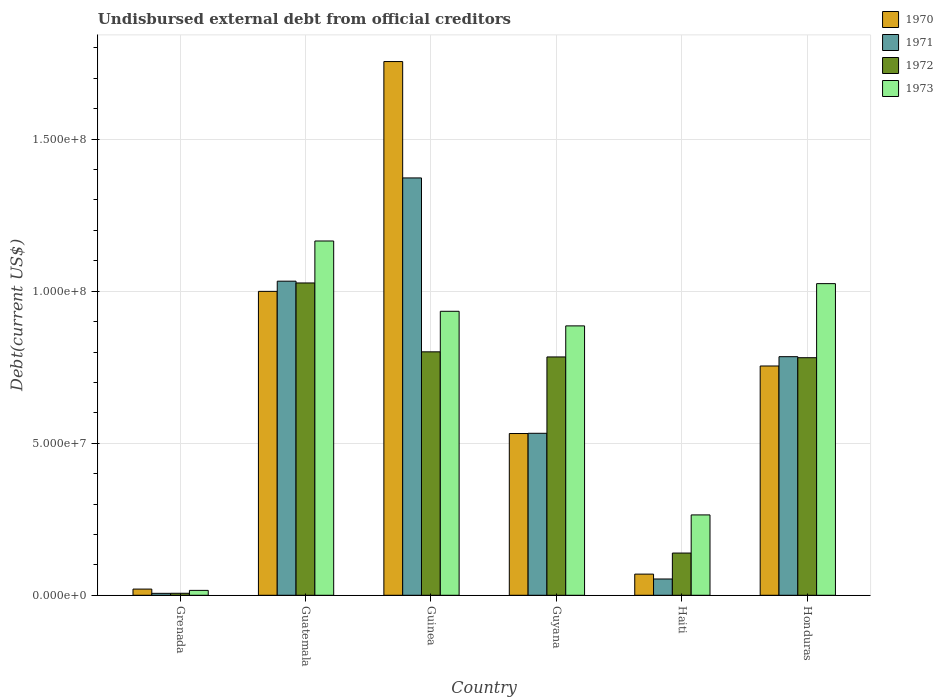Are the number of bars per tick equal to the number of legend labels?
Offer a terse response. Yes. How many bars are there on the 6th tick from the left?
Offer a very short reply. 4. How many bars are there on the 3rd tick from the right?
Your answer should be very brief. 4. What is the label of the 1st group of bars from the left?
Your answer should be very brief. Grenada. What is the total debt in 1970 in Haiti?
Give a very brief answer. 6.96e+06. Across all countries, what is the maximum total debt in 1971?
Give a very brief answer. 1.37e+08. Across all countries, what is the minimum total debt in 1972?
Make the answer very short. 6.57e+05. In which country was the total debt in 1973 maximum?
Provide a succinct answer. Guatemala. In which country was the total debt in 1970 minimum?
Provide a short and direct response. Grenada. What is the total total debt in 1972 in the graph?
Give a very brief answer. 3.54e+08. What is the difference between the total debt in 1973 in Guyana and that in Haiti?
Offer a terse response. 6.22e+07. What is the difference between the total debt in 1972 in Honduras and the total debt in 1970 in Grenada?
Your answer should be very brief. 7.61e+07. What is the average total debt in 1972 per country?
Provide a short and direct response. 5.90e+07. What is the difference between the total debt of/in 1973 and total debt of/in 1970 in Honduras?
Your response must be concise. 2.71e+07. What is the ratio of the total debt in 1973 in Guatemala to that in Guinea?
Make the answer very short. 1.25. Is the difference between the total debt in 1973 in Grenada and Guyana greater than the difference between the total debt in 1970 in Grenada and Guyana?
Your answer should be very brief. No. What is the difference between the highest and the second highest total debt in 1970?
Your answer should be compact. 1.00e+08. What is the difference between the highest and the lowest total debt in 1972?
Give a very brief answer. 1.02e+08. In how many countries, is the total debt in 1972 greater than the average total debt in 1972 taken over all countries?
Keep it short and to the point. 4. Is the sum of the total debt in 1972 in Guinea and Guyana greater than the maximum total debt in 1973 across all countries?
Your answer should be compact. Yes. Is it the case that in every country, the sum of the total debt in 1973 and total debt in 1970 is greater than the sum of total debt in 1972 and total debt in 1971?
Offer a terse response. No. What does the 2nd bar from the right in Guatemala represents?
Give a very brief answer. 1972. How many countries are there in the graph?
Provide a short and direct response. 6. What is the difference between two consecutive major ticks on the Y-axis?
Offer a very short reply. 5.00e+07. Are the values on the major ticks of Y-axis written in scientific E-notation?
Provide a short and direct response. Yes. Does the graph contain any zero values?
Keep it short and to the point. No. Does the graph contain grids?
Your answer should be very brief. Yes. Where does the legend appear in the graph?
Give a very brief answer. Top right. How many legend labels are there?
Offer a terse response. 4. How are the legend labels stacked?
Your answer should be compact. Vertical. What is the title of the graph?
Ensure brevity in your answer.  Undisbursed external debt from official creditors. Does "2014" appear as one of the legend labels in the graph?
Your response must be concise. No. What is the label or title of the X-axis?
Your answer should be very brief. Country. What is the label or title of the Y-axis?
Provide a succinct answer. Debt(current US$). What is the Debt(current US$) of 1970 in Grenada?
Your answer should be very brief. 2.04e+06. What is the Debt(current US$) of 1971 in Grenada?
Your answer should be very brief. 6.39e+05. What is the Debt(current US$) of 1972 in Grenada?
Your response must be concise. 6.57e+05. What is the Debt(current US$) in 1973 in Grenada?
Make the answer very short. 1.61e+06. What is the Debt(current US$) of 1970 in Guatemala?
Offer a terse response. 9.99e+07. What is the Debt(current US$) of 1971 in Guatemala?
Keep it short and to the point. 1.03e+08. What is the Debt(current US$) of 1972 in Guatemala?
Provide a short and direct response. 1.03e+08. What is the Debt(current US$) in 1973 in Guatemala?
Your answer should be compact. 1.17e+08. What is the Debt(current US$) in 1970 in Guinea?
Provide a succinct answer. 1.76e+08. What is the Debt(current US$) in 1971 in Guinea?
Your response must be concise. 1.37e+08. What is the Debt(current US$) in 1972 in Guinea?
Provide a short and direct response. 8.01e+07. What is the Debt(current US$) in 1973 in Guinea?
Provide a short and direct response. 9.34e+07. What is the Debt(current US$) in 1970 in Guyana?
Keep it short and to the point. 5.32e+07. What is the Debt(current US$) of 1971 in Guyana?
Your answer should be compact. 5.33e+07. What is the Debt(current US$) in 1972 in Guyana?
Your answer should be very brief. 7.84e+07. What is the Debt(current US$) in 1973 in Guyana?
Provide a short and direct response. 8.86e+07. What is the Debt(current US$) in 1970 in Haiti?
Give a very brief answer. 6.96e+06. What is the Debt(current US$) of 1971 in Haiti?
Provide a succinct answer. 5.35e+06. What is the Debt(current US$) in 1972 in Haiti?
Give a very brief answer. 1.39e+07. What is the Debt(current US$) of 1973 in Haiti?
Provide a succinct answer. 2.64e+07. What is the Debt(current US$) in 1970 in Honduras?
Your response must be concise. 7.54e+07. What is the Debt(current US$) in 1971 in Honduras?
Keep it short and to the point. 7.85e+07. What is the Debt(current US$) of 1972 in Honduras?
Give a very brief answer. 7.81e+07. What is the Debt(current US$) in 1973 in Honduras?
Offer a very short reply. 1.02e+08. Across all countries, what is the maximum Debt(current US$) of 1970?
Your response must be concise. 1.76e+08. Across all countries, what is the maximum Debt(current US$) in 1971?
Your answer should be compact. 1.37e+08. Across all countries, what is the maximum Debt(current US$) of 1972?
Make the answer very short. 1.03e+08. Across all countries, what is the maximum Debt(current US$) of 1973?
Provide a short and direct response. 1.17e+08. Across all countries, what is the minimum Debt(current US$) of 1970?
Make the answer very short. 2.04e+06. Across all countries, what is the minimum Debt(current US$) in 1971?
Your response must be concise. 6.39e+05. Across all countries, what is the minimum Debt(current US$) in 1972?
Your answer should be very brief. 6.57e+05. Across all countries, what is the minimum Debt(current US$) of 1973?
Ensure brevity in your answer.  1.61e+06. What is the total Debt(current US$) in 1970 in the graph?
Your response must be concise. 4.13e+08. What is the total Debt(current US$) of 1971 in the graph?
Make the answer very short. 3.78e+08. What is the total Debt(current US$) of 1972 in the graph?
Ensure brevity in your answer.  3.54e+08. What is the total Debt(current US$) of 1973 in the graph?
Offer a very short reply. 4.29e+08. What is the difference between the Debt(current US$) of 1970 in Grenada and that in Guatemala?
Your answer should be compact. -9.79e+07. What is the difference between the Debt(current US$) of 1971 in Grenada and that in Guatemala?
Offer a very short reply. -1.03e+08. What is the difference between the Debt(current US$) in 1972 in Grenada and that in Guatemala?
Your response must be concise. -1.02e+08. What is the difference between the Debt(current US$) of 1973 in Grenada and that in Guatemala?
Keep it short and to the point. -1.15e+08. What is the difference between the Debt(current US$) of 1970 in Grenada and that in Guinea?
Offer a very short reply. -1.73e+08. What is the difference between the Debt(current US$) in 1971 in Grenada and that in Guinea?
Ensure brevity in your answer.  -1.37e+08. What is the difference between the Debt(current US$) in 1972 in Grenada and that in Guinea?
Make the answer very short. -7.94e+07. What is the difference between the Debt(current US$) in 1973 in Grenada and that in Guinea?
Offer a very short reply. -9.18e+07. What is the difference between the Debt(current US$) in 1970 in Grenada and that in Guyana?
Make the answer very short. -5.12e+07. What is the difference between the Debt(current US$) in 1971 in Grenada and that in Guyana?
Your response must be concise. -5.26e+07. What is the difference between the Debt(current US$) of 1972 in Grenada and that in Guyana?
Keep it short and to the point. -7.77e+07. What is the difference between the Debt(current US$) in 1973 in Grenada and that in Guyana?
Provide a succinct answer. -8.70e+07. What is the difference between the Debt(current US$) of 1970 in Grenada and that in Haiti?
Provide a succinct answer. -4.92e+06. What is the difference between the Debt(current US$) in 1971 in Grenada and that in Haiti?
Ensure brevity in your answer.  -4.71e+06. What is the difference between the Debt(current US$) in 1972 in Grenada and that in Haiti?
Give a very brief answer. -1.32e+07. What is the difference between the Debt(current US$) in 1973 in Grenada and that in Haiti?
Keep it short and to the point. -2.48e+07. What is the difference between the Debt(current US$) in 1970 in Grenada and that in Honduras?
Offer a very short reply. -7.34e+07. What is the difference between the Debt(current US$) of 1971 in Grenada and that in Honduras?
Your answer should be compact. -7.78e+07. What is the difference between the Debt(current US$) of 1972 in Grenada and that in Honduras?
Give a very brief answer. -7.75e+07. What is the difference between the Debt(current US$) of 1973 in Grenada and that in Honduras?
Offer a terse response. -1.01e+08. What is the difference between the Debt(current US$) in 1970 in Guatemala and that in Guinea?
Your answer should be very brief. -7.56e+07. What is the difference between the Debt(current US$) of 1971 in Guatemala and that in Guinea?
Ensure brevity in your answer.  -3.40e+07. What is the difference between the Debt(current US$) in 1972 in Guatemala and that in Guinea?
Your answer should be compact. 2.27e+07. What is the difference between the Debt(current US$) of 1973 in Guatemala and that in Guinea?
Make the answer very short. 2.31e+07. What is the difference between the Debt(current US$) in 1970 in Guatemala and that in Guyana?
Your answer should be very brief. 4.67e+07. What is the difference between the Debt(current US$) of 1971 in Guatemala and that in Guyana?
Make the answer very short. 5.00e+07. What is the difference between the Debt(current US$) in 1972 in Guatemala and that in Guyana?
Provide a short and direct response. 2.43e+07. What is the difference between the Debt(current US$) of 1973 in Guatemala and that in Guyana?
Keep it short and to the point. 2.79e+07. What is the difference between the Debt(current US$) in 1970 in Guatemala and that in Haiti?
Make the answer very short. 9.30e+07. What is the difference between the Debt(current US$) of 1971 in Guatemala and that in Haiti?
Provide a short and direct response. 9.79e+07. What is the difference between the Debt(current US$) of 1972 in Guatemala and that in Haiti?
Your answer should be compact. 8.88e+07. What is the difference between the Debt(current US$) of 1973 in Guatemala and that in Haiti?
Ensure brevity in your answer.  9.01e+07. What is the difference between the Debt(current US$) of 1970 in Guatemala and that in Honduras?
Offer a terse response. 2.45e+07. What is the difference between the Debt(current US$) of 1971 in Guatemala and that in Honduras?
Keep it short and to the point. 2.48e+07. What is the difference between the Debt(current US$) of 1972 in Guatemala and that in Honduras?
Ensure brevity in your answer.  2.46e+07. What is the difference between the Debt(current US$) in 1973 in Guatemala and that in Honduras?
Ensure brevity in your answer.  1.40e+07. What is the difference between the Debt(current US$) of 1970 in Guinea and that in Guyana?
Make the answer very short. 1.22e+08. What is the difference between the Debt(current US$) in 1971 in Guinea and that in Guyana?
Your answer should be compact. 8.40e+07. What is the difference between the Debt(current US$) in 1972 in Guinea and that in Guyana?
Your response must be concise. 1.68e+06. What is the difference between the Debt(current US$) of 1973 in Guinea and that in Guyana?
Provide a short and direct response. 4.80e+06. What is the difference between the Debt(current US$) in 1970 in Guinea and that in Haiti?
Ensure brevity in your answer.  1.69e+08. What is the difference between the Debt(current US$) in 1971 in Guinea and that in Haiti?
Your answer should be compact. 1.32e+08. What is the difference between the Debt(current US$) of 1972 in Guinea and that in Haiti?
Your response must be concise. 6.62e+07. What is the difference between the Debt(current US$) in 1973 in Guinea and that in Haiti?
Your answer should be very brief. 6.70e+07. What is the difference between the Debt(current US$) in 1970 in Guinea and that in Honduras?
Your response must be concise. 1.00e+08. What is the difference between the Debt(current US$) of 1971 in Guinea and that in Honduras?
Ensure brevity in your answer.  5.88e+07. What is the difference between the Debt(current US$) of 1972 in Guinea and that in Honduras?
Your answer should be very brief. 1.93e+06. What is the difference between the Debt(current US$) of 1973 in Guinea and that in Honduras?
Provide a succinct answer. -9.10e+06. What is the difference between the Debt(current US$) of 1970 in Guyana and that in Haiti?
Keep it short and to the point. 4.62e+07. What is the difference between the Debt(current US$) of 1971 in Guyana and that in Haiti?
Provide a succinct answer. 4.79e+07. What is the difference between the Debt(current US$) of 1972 in Guyana and that in Haiti?
Your response must be concise. 6.45e+07. What is the difference between the Debt(current US$) in 1973 in Guyana and that in Haiti?
Give a very brief answer. 6.22e+07. What is the difference between the Debt(current US$) of 1970 in Guyana and that in Honduras?
Your response must be concise. -2.22e+07. What is the difference between the Debt(current US$) of 1971 in Guyana and that in Honduras?
Offer a terse response. -2.52e+07. What is the difference between the Debt(current US$) of 1972 in Guyana and that in Honduras?
Keep it short and to the point. 2.49e+05. What is the difference between the Debt(current US$) in 1973 in Guyana and that in Honduras?
Your answer should be very brief. -1.39e+07. What is the difference between the Debt(current US$) in 1970 in Haiti and that in Honduras?
Make the answer very short. -6.84e+07. What is the difference between the Debt(current US$) of 1971 in Haiti and that in Honduras?
Your answer should be very brief. -7.31e+07. What is the difference between the Debt(current US$) in 1972 in Haiti and that in Honduras?
Keep it short and to the point. -6.42e+07. What is the difference between the Debt(current US$) in 1973 in Haiti and that in Honduras?
Provide a short and direct response. -7.61e+07. What is the difference between the Debt(current US$) of 1970 in Grenada and the Debt(current US$) of 1971 in Guatemala?
Offer a terse response. -1.01e+08. What is the difference between the Debt(current US$) of 1970 in Grenada and the Debt(current US$) of 1972 in Guatemala?
Give a very brief answer. -1.01e+08. What is the difference between the Debt(current US$) in 1970 in Grenada and the Debt(current US$) in 1973 in Guatemala?
Your answer should be very brief. -1.14e+08. What is the difference between the Debt(current US$) of 1971 in Grenada and the Debt(current US$) of 1972 in Guatemala?
Your response must be concise. -1.02e+08. What is the difference between the Debt(current US$) in 1971 in Grenada and the Debt(current US$) in 1973 in Guatemala?
Your answer should be compact. -1.16e+08. What is the difference between the Debt(current US$) of 1972 in Grenada and the Debt(current US$) of 1973 in Guatemala?
Your response must be concise. -1.16e+08. What is the difference between the Debt(current US$) in 1970 in Grenada and the Debt(current US$) in 1971 in Guinea?
Offer a terse response. -1.35e+08. What is the difference between the Debt(current US$) of 1970 in Grenada and the Debt(current US$) of 1972 in Guinea?
Keep it short and to the point. -7.80e+07. What is the difference between the Debt(current US$) in 1970 in Grenada and the Debt(current US$) in 1973 in Guinea?
Provide a succinct answer. -9.14e+07. What is the difference between the Debt(current US$) in 1971 in Grenada and the Debt(current US$) in 1972 in Guinea?
Your answer should be very brief. -7.94e+07. What is the difference between the Debt(current US$) of 1971 in Grenada and the Debt(current US$) of 1973 in Guinea?
Ensure brevity in your answer.  -9.28e+07. What is the difference between the Debt(current US$) of 1972 in Grenada and the Debt(current US$) of 1973 in Guinea?
Your answer should be compact. -9.27e+07. What is the difference between the Debt(current US$) of 1970 in Grenada and the Debt(current US$) of 1971 in Guyana?
Your answer should be very brief. -5.12e+07. What is the difference between the Debt(current US$) in 1970 in Grenada and the Debt(current US$) in 1972 in Guyana?
Your response must be concise. -7.63e+07. What is the difference between the Debt(current US$) in 1970 in Grenada and the Debt(current US$) in 1973 in Guyana?
Offer a very short reply. -8.66e+07. What is the difference between the Debt(current US$) in 1971 in Grenada and the Debt(current US$) in 1972 in Guyana?
Provide a succinct answer. -7.77e+07. What is the difference between the Debt(current US$) in 1971 in Grenada and the Debt(current US$) in 1973 in Guyana?
Give a very brief answer. -8.80e+07. What is the difference between the Debt(current US$) in 1972 in Grenada and the Debt(current US$) in 1973 in Guyana?
Offer a terse response. -8.79e+07. What is the difference between the Debt(current US$) of 1970 in Grenada and the Debt(current US$) of 1971 in Haiti?
Give a very brief answer. -3.32e+06. What is the difference between the Debt(current US$) in 1970 in Grenada and the Debt(current US$) in 1972 in Haiti?
Provide a short and direct response. -1.18e+07. What is the difference between the Debt(current US$) of 1970 in Grenada and the Debt(current US$) of 1973 in Haiti?
Your response must be concise. -2.44e+07. What is the difference between the Debt(current US$) in 1971 in Grenada and the Debt(current US$) in 1972 in Haiti?
Your response must be concise. -1.32e+07. What is the difference between the Debt(current US$) in 1971 in Grenada and the Debt(current US$) in 1973 in Haiti?
Provide a short and direct response. -2.58e+07. What is the difference between the Debt(current US$) in 1972 in Grenada and the Debt(current US$) in 1973 in Haiti?
Give a very brief answer. -2.58e+07. What is the difference between the Debt(current US$) of 1970 in Grenada and the Debt(current US$) of 1971 in Honduras?
Keep it short and to the point. -7.64e+07. What is the difference between the Debt(current US$) of 1970 in Grenada and the Debt(current US$) of 1972 in Honduras?
Make the answer very short. -7.61e+07. What is the difference between the Debt(current US$) of 1970 in Grenada and the Debt(current US$) of 1973 in Honduras?
Offer a very short reply. -1.00e+08. What is the difference between the Debt(current US$) of 1971 in Grenada and the Debt(current US$) of 1972 in Honduras?
Ensure brevity in your answer.  -7.75e+07. What is the difference between the Debt(current US$) in 1971 in Grenada and the Debt(current US$) in 1973 in Honduras?
Keep it short and to the point. -1.02e+08. What is the difference between the Debt(current US$) in 1972 in Grenada and the Debt(current US$) in 1973 in Honduras?
Ensure brevity in your answer.  -1.02e+08. What is the difference between the Debt(current US$) of 1970 in Guatemala and the Debt(current US$) of 1971 in Guinea?
Ensure brevity in your answer.  -3.73e+07. What is the difference between the Debt(current US$) of 1970 in Guatemala and the Debt(current US$) of 1972 in Guinea?
Keep it short and to the point. 1.99e+07. What is the difference between the Debt(current US$) of 1970 in Guatemala and the Debt(current US$) of 1973 in Guinea?
Give a very brief answer. 6.55e+06. What is the difference between the Debt(current US$) of 1971 in Guatemala and the Debt(current US$) of 1972 in Guinea?
Your answer should be very brief. 2.32e+07. What is the difference between the Debt(current US$) in 1971 in Guatemala and the Debt(current US$) in 1973 in Guinea?
Ensure brevity in your answer.  9.90e+06. What is the difference between the Debt(current US$) of 1972 in Guatemala and the Debt(current US$) of 1973 in Guinea?
Make the answer very short. 9.32e+06. What is the difference between the Debt(current US$) in 1970 in Guatemala and the Debt(current US$) in 1971 in Guyana?
Offer a terse response. 4.67e+07. What is the difference between the Debt(current US$) in 1970 in Guatemala and the Debt(current US$) in 1972 in Guyana?
Provide a short and direct response. 2.16e+07. What is the difference between the Debt(current US$) in 1970 in Guatemala and the Debt(current US$) in 1973 in Guyana?
Provide a short and direct response. 1.14e+07. What is the difference between the Debt(current US$) of 1971 in Guatemala and the Debt(current US$) of 1972 in Guyana?
Ensure brevity in your answer.  2.49e+07. What is the difference between the Debt(current US$) in 1971 in Guatemala and the Debt(current US$) in 1973 in Guyana?
Your response must be concise. 1.47e+07. What is the difference between the Debt(current US$) in 1972 in Guatemala and the Debt(current US$) in 1973 in Guyana?
Provide a short and direct response. 1.41e+07. What is the difference between the Debt(current US$) in 1970 in Guatemala and the Debt(current US$) in 1971 in Haiti?
Offer a very short reply. 9.46e+07. What is the difference between the Debt(current US$) of 1970 in Guatemala and the Debt(current US$) of 1972 in Haiti?
Your answer should be very brief. 8.61e+07. What is the difference between the Debt(current US$) in 1970 in Guatemala and the Debt(current US$) in 1973 in Haiti?
Your answer should be compact. 7.35e+07. What is the difference between the Debt(current US$) of 1971 in Guatemala and the Debt(current US$) of 1972 in Haiti?
Provide a short and direct response. 8.94e+07. What is the difference between the Debt(current US$) in 1971 in Guatemala and the Debt(current US$) in 1973 in Haiti?
Make the answer very short. 7.69e+07. What is the difference between the Debt(current US$) of 1972 in Guatemala and the Debt(current US$) of 1973 in Haiti?
Your answer should be compact. 7.63e+07. What is the difference between the Debt(current US$) of 1970 in Guatemala and the Debt(current US$) of 1971 in Honduras?
Ensure brevity in your answer.  2.15e+07. What is the difference between the Debt(current US$) in 1970 in Guatemala and the Debt(current US$) in 1972 in Honduras?
Offer a terse response. 2.18e+07. What is the difference between the Debt(current US$) of 1970 in Guatemala and the Debt(current US$) of 1973 in Honduras?
Ensure brevity in your answer.  -2.55e+06. What is the difference between the Debt(current US$) in 1971 in Guatemala and the Debt(current US$) in 1972 in Honduras?
Make the answer very short. 2.52e+07. What is the difference between the Debt(current US$) of 1971 in Guatemala and the Debt(current US$) of 1973 in Honduras?
Give a very brief answer. 8.06e+05. What is the difference between the Debt(current US$) of 1972 in Guatemala and the Debt(current US$) of 1973 in Honduras?
Your response must be concise. 2.19e+05. What is the difference between the Debt(current US$) in 1970 in Guinea and the Debt(current US$) in 1971 in Guyana?
Your answer should be very brief. 1.22e+08. What is the difference between the Debt(current US$) in 1970 in Guinea and the Debt(current US$) in 1972 in Guyana?
Give a very brief answer. 9.71e+07. What is the difference between the Debt(current US$) in 1970 in Guinea and the Debt(current US$) in 1973 in Guyana?
Offer a terse response. 8.69e+07. What is the difference between the Debt(current US$) of 1971 in Guinea and the Debt(current US$) of 1972 in Guyana?
Make the answer very short. 5.89e+07. What is the difference between the Debt(current US$) of 1971 in Guinea and the Debt(current US$) of 1973 in Guyana?
Your answer should be very brief. 4.87e+07. What is the difference between the Debt(current US$) in 1972 in Guinea and the Debt(current US$) in 1973 in Guyana?
Ensure brevity in your answer.  -8.54e+06. What is the difference between the Debt(current US$) in 1970 in Guinea and the Debt(current US$) in 1971 in Haiti?
Make the answer very short. 1.70e+08. What is the difference between the Debt(current US$) of 1970 in Guinea and the Debt(current US$) of 1972 in Haiti?
Provide a succinct answer. 1.62e+08. What is the difference between the Debt(current US$) of 1970 in Guinea and the Debt(current US$) of 1973 in Haiti?
Keep it short and to the point. 1.49e+08. What is the difference between the Debt(current US$) in 1971 in Guinea and the Debt(current US$) in 1972 in Haiti?
Give a very brief answer. 1.23e+08. What is the difference between the Debt(current US$) of 1971 in Guinea and the Debt(current US$) of 1973 in Haiti?
Make the answer very short. 1.11e+08. What is the difference between the Debt(current US$) of 1972 in Guinea and the Debt(current US$) of 1973 in Haiti?
Make the answer very short. 5.36e+07. What is the difference between the Debt(current US$) in 1970 in Guinea and the Debt(current US$) in 1971 in Honduras?
Provide a succinct answer. 9.71e+07. What is the difference between the Debt(current US$) of 1970 in Guinea and the Debt(current US$) of 1972 in Honduras?
Keep it short and to the point. 9.74e+07. What is the difference between the Debt(current US$) of 1970 in Guinea and the Debt(current US$) of 1973 in Honduras?
Your answer should be very brief. 7.30e+07. What is the difference between the Debt(current US$) in 1971 in Guinea and the Debt(current US$) in 1972 in Honduras?
Make the answer very short. 5.91e+07. What is the difference between the Debt(current US$) of 1971 in Guinea and the Debt(current US$) of 1973 in Honduras?
Your answer should be compact. 3.48e+07. What is the difference between the Debt(current US$) in 1972 in Guinea and the Debt(current US$) in 1973 in Honduras?
Provide a succinct answer. -2.24e+07. What is the difference between the Debt(current US$) in 1970 in Guyana and the Debt(current US$) in 1971 in Haiti?
Provide a short and direct response. 4.78e+07. What is the difference between the Debt(current US$) in 1970 in Guyana and the Debt(current US$) in 1972 in Haiti?
Your answer should be very brief. 3.93e+07. What is the difference between the Debt(current US$) in 1970 in Guyana and the Debt(current US$) in 1973 in Haiti?
Offer a terse response. 2.68e+07. What is the difference between the Debt(current US$) in 1971 in Guyana and the Debt(current US$) in 1972 in Haiti?
Keep it short and to the point. 3.94e+07. What is the difference between the Debt(current US$) in 1971 in Guyana and the Debt(current US$) in 1973 in Haiti?
Provide a succinct answer. 2.68e+07. What is the difference between the Debt(current US$) in 1972 in Guyana and the Debt(current US$) in 1973 in Haiti?
Make the answer very short. 5.19e+07. What is the difference between the Debt(current US$) of 1970 in Guyana and the Debt(current US$) of 1971 in Honduras?
Keep it short and to the point. -2.53e+07. What is the difference between the Debt(current US$) of 1970 in Guyana and the Debt(current US$) of 1972 in Honduras?
Offer a very short reply. -2.49e+07. What is the difference between the Debt(current US$) of 1970 in Guyana and the Debt(current US$) of 1973 in Honduras?
Provide a succinct answer. -4.93e+07. What is the difference between the Debt(current US$) in 1971 in Guyana and the Debt(current US$) in 1972 in Honduras?
Provide a succinct answer. -2.49e+07. What is the difference between the Debt(current US$) of 1971 in Guyana and the Debt(current US$) of 1973 in Honduras?
Ensure brevity in your answer.  -4.92e+07. What is the difference between the Debt(current US$) of 1972 in Guyana and the Debt(current US$) of 1973 in Honduras?
Your answer should be very brief. -2.41e+07. What is the difference between the Debt(current US$) of 1970 in Haiti and the Debt(current US$) of 1971 in Honduras?
Make the answer very short. -7.15e+07. What is the difference between the Debt(current US$) of 1970 in Haiti and the Debt(current US$) of 1972 in Honduras?
Make the answer very short. -7.12e+07. What is the difference between the Debt(current US$) in 1970 in Haiti and the Debt(current US$) in 1973 in Honduras?
Your response must be concise. -9.55e+07. What is the difference between the Debt(current US$) in 1971 in Haiti and the Debt(current US$) in 1972 in Honduras?
Offer a terse response. -7.28e+07. What is the difference between the Debt(current US$) of 1971 in Haiti and the Debt(current US$) of 1973 in Honduras?
Your answer should be compact. -9.71e+07. What is the difference between the Debt(current US$) of 1972 in Haiti and the Debt(current US$) of 1973 in Honduras?
Offer a terse response. -8.86e+07. What is the average Debt(current US$) in 1970 per country?
Give a very brief answer. 6.88e+07. What is the average Debt(current US$) in 1971 per country?
Provide a short and direct response. 6.30e+07. What is the average Debt(current US$) in 1972 per country?
Keep it short and to the point. 5.90e+07. What is the average Debt(current US$) of 1973 per country?
Keep it short and to the point. 7.15e+07. What is the difference between the Debt(current US$) in 1970 and Debt(current US$) in 1971 in Grenada?
Your answer should be very brief. 1.40e+06. What is the difference between the Debt(current US$) in 1970 and Debt(current US$) in 1972 in Grenada?
Your answer should be compact. 1.38e+06. What is the difference between the Debt(current US$) of 1970 and Debt(current US$) of 1973 in Grenada?
Provide a succinct answer. 4.26e+05. What is the difference between the Debt(current US$) of 1971 and Debt(current US$) of 1972 in Grenada?
Give a very brief answer. -1.80e+04. What is the difference between the Debt(current US$) in 1971 and Debt(current US$) in 1973 in Grenada?
Your response must be concise. -9.72e+05. What is the difference between the Debt(current US$) in 1972 and Debt(current US$) in 1973 in Grenada?
Ensure brevity in your answer.  -9.54e+05. What is the difference between the Debt(current US$) in 1970 and Debt(current US$) in 1971 in Guatemala?
Keep it short and to the point. -3.35e+06. What is the difference between the Debt(current US$) in 1970 and Debt(current US$) in 1972 in Guatemala?
Provide a succinct answer. -2.77e+06. What is the difference between the Debt(current US$) in 1970 and Debt(current US$) in 1973 in Guatemala?
Offer a very short reply. -1.66e+07. What is the difference between the Debt(current US$) in 1971 and Debt(current US$) in 1972 in Guatemala?
Your answer should be very brief. 5.87e+05. What is the difference between the Debt(current US$) of 1971 and Debt(current US$) of 1973 in Guatemala?
Make the answer very short. -1.32e+07. What is the difference between the Debt(current US$) of 1972 and Debt(current US$) of 1973 in Guatemala?
Give a very brief answer. -1.38e+07. What is the difference between the Debt(current US$) of 1970 and Debt(current US$) of 1971 in Guinea?
Provide a short and direct response. 3.83e+07. What is the difference between the Debt(current US$) of 1970 and Debt(current US$) of 1972 in Guinea?
Keep it short and to the point. 9.55e+07. What is the difference between the Debt(current US$) in 1970 and Debt(current US$) in 1973 in Guinea?
Keep it short and to the point. 8.21e+07. What is the difference between the Debt(current US$) of 1971 and Debt(current US$) of 1972 in Guinea?
Your answer should be very brief. 5.72e+07. What is the difference between the Debt(current US$) of 1971 and Debt(current US$) of 1973 in Guinea?
Keep it short and to the point. 4.39e+07. What is the difference between the Debt(current US$) of 1972 and Debt(current US$) of 1973 in Guinea?
Your answer should be compact. -1.33e+07. What is the difference between the Debt(current US$) in 1970 and Debt(current US$) in 1971 in Guyana?
Your answer should be very brief. -7.30e+04. What is the difference between the Debt(current US$) in 1970 and Debt(current US$) in 1972 in Guyana?
Provide a succinct answer. -2.52e+07. What is the difference between the Debt(current US$) of 1970 and Debt(current US$) of 1973 in Guyana?
Your answer should be very brief. -3.54e+07. What is the difference between the Debt(current US$) of 1971 and Debt(current US$) of 1972 in Guyana?
Give a very brief answer. -2.51e+07. What is the difference between the Debt(current US$) in 1971 and Debt(current US$) in 1973 in Guyana?
Give a very brief answer. -3.53e+07. What is the difference between the Debt(current US$) of 1972 and Debt(current US$) of 1973 in Guyana?
Offer a very short reply. -1.02e+07. What is the difference between the Debt(current US$) in 1970 and Debt(current US$) in 1971 in Haiti?
Make the answer very short. 1.61e+06. What is the difference between the Debt(current US$) in 1970 and Debt(current US$) in 1972 in Haiti?
Provide a succinct answer. -6.92e+06. What is the difference between the Debt(current US$) in 1970 and Debt(current US$) in 1973 in Haiti?
Your answer should be compact. -1.95e+07. What is the difference between the Debt(current US$) of 1971 and Debt(current US$) of 1972 in Haiti?
Give a very brief answer. -8.53e+06. What is the difference between the Debt(current US$) of 1971 and Debt(current US$) of 1973 in Haiti?
Ensure brevity in your answer.  -2.11e+07. What is the difference between the Debt(current US$) of 1972 and Debt(current US$) of 1973 in Haiti?
Keep it short and to the point. -1.25e+07. What is the difference between the Debt(current US$) of 1970 and Debt(current US$) of 1971 in Honduras?
Offer a terse response. -3.06e+06. What is the difference between the Debt(current US$) in 1970 and Debt(current US$) in 1972 in Honduras?
Your answer should be very brief. -2.72e+06. What is the difference between the Debt(current US$) in 1970 and Debt(current US$) in 1973 in Honduras?
Your answer should be very brief. -2.71e+07. What is the difference between the Debt(current US$) in 1971 and Debt(current US$) in 1972 in Honduras?
Provide a succinct answer. 3.37e+05. What is the difference between the Debt(current US$) of 1971 and Debt(current US$) of 1973 in Honduras?
Make the answer very short. -2.40e+07. What is the difference between the Debt(current US$) of 1972 and Debt(current US$) of 1973 in Honduras?
Give a very brief answer. -2.44e+07. What is the ratio of the Debt(current US$) of 1970 in Grenada to that in Guatemala?
Make the answer very short. 0.02. What is the ratio of the Debt(current US$) of 1971 in Grenada to that in Guatemala?
Give a very brief answer. 0.01. What is the ratio of the Debt(current US$) in 1972 in Grenada to that in Guatemala?
Make the answer very short. 0.01. What is the ratio of the Debt(current US$) of 1973 in Grenada to that in Guatemala?
Your answer should be compact. 0.01. What is the ratio of the Debt(current US$) in 1970 in Grenada to that in Guinea?
Give a very brief answer. 0.01. What is the ratio of the Debt(current US$) in 1971 in Grenada to that in Guinea?
Keep it short and to the point. 0. What is the ratio of the Debt(current US$) in 1972 in Grenada to that in Guinea?
Your answer should be very brief. 0.01. What is the ratio of the Debt(current US$) in 1973 in Grenada to that in Guinea?
Your answer should be very brief. 0.02. What is the ratio of the Debt(current US$) in 1970 in Grenada to that in Guyana?
Offer a very short reply. 0.04. What is the ratio of the Debt(current US$) of 1971 in Grenada to that in Guyana?
Give a very brief answer. 0.01. What is the ratio of the Debt(current US$) of 1972 in Grenada to that in Guyana?
Offer a terse response. 0.01. What is the ratio of the Debt(current US$) in 1973 in Grenada to that in Guyana?
Offer a very short reply. 0.02. What is the ratio of the Debt(current US$) of 1970 in Grenada to that in Haiti?
Keep it short and to the point. 0.29. What is the ratio of the Debt(current US$) of 1971 in Grenada to that in Haiti?
Give a very brief answer. 0.12. What is the ratio of the Debt(current US$) of 1972 in Grenada to that in Haiti?
Offer a terse response. 0.05. What is the ratio of the Debt(current US$) of 1973 in Grenada to that in Haiti?
Your answer should be very brief. 0.06. What is the ratio of the Debt(current US$) in 1970 in Grenada to that in Honduras?
Provide a short and direct response. 0.03. What is the ratio of the Debt(current US$) of 1971 in Grenada to that in Honduras?
Your answer should be compact. 0.01. What is the ratio of the Debt(current US$) of 1972 in Grenada to that in Honduras?
Your answer should be compact. 0.01. What is the ratio of the Debt(current US$) in 1973 in Grenada to that in Honduras?
Your response must be concise. 0.02. What is the ratio of the Debt(current US$) in 1970 in Guatemala to that in Guinea?
Offer a very short reply. 0.57. What is the ratio of the Debt(current US$) in 1971 in Guatemala to that in Guinea?
Keep it short and to the point. 0.75. What is the ratio of the Debt(current US$) in 1972 in Guatemala to that in Guinea?
Your answer should be compact. 1.28. What is the ratio of the Debt(current US$) in 1973 in Guatemala to that in Guinea?
Your response must be concise. 1.25. What is the ratio of the Debt(current US$) in 1970 in Guatemala to that in Guyana?
Offer a terse response. 1.88. What is the ratio of the Debt(current US$) of 1971 in Guatemala to that in Guyana?
Your response must be concise. 1.94. What is the ratio of the Debt(current US$) in 1972 in Guatemala to that in Guyana?
Your answer should be very brief. 1.31. What is the ratio of the Debt(current US$) in 1973 in Guatemala to that in Guyana?
Offer a very short reply. 1.32. What is the ratio of the Debt(current US$) of 1970 in Guatemala to that in Haiti?
Give a very brief answer. 14.36. What is the ratio of the Debt(current US$) in 1971 in Guatemala to that in Haiti?
Make the answer very short. 19.3. What is the ratio of the Debt(current US$) in 1972 in Guatemala to that in Haiti?
Your answer should be compact. 7.4. What is the ratio of the Debt(current US$) in 1973 in Guatemala to that in Haiti?
Give a very brief answer. 4.41. What is the ratio of the Debt(current US$) in 1970 in Guatemala to that in Honduras?
Offer a terse response. 1.33. What is the ratio of the Debt(current US$) of 1971 in Guatemala to that in Honduras?
Provide a short and direct response. 1.32. What is the ratio of the Debt(current US$) in 1972 in Guatemala to that in Honduras?
Offer a very short reply. 1.31. What is the ratio of the Debt(current US$) of 1973 in Guatemala to that in Honduras?
Provide a short and direct response. 1.14. What is the ratio of the Debt(current US$) in 1970 in Guinea to that in Guyana?
Keep it short and to the point. 3.3. What is the ratio of the Debt(current US$) in 1971 in Guinea to that in Guyana?
Your answer should be compact. 2.58. What is the ratio of the Debt(current US$) in 1972 in Guinea to that in Guyana?
Provide a short and direct response. 1.02. What is the ratio of the Debt(current US$) of 1973 in Guinea to that in Guyana?
Keep it short and to the point. 1.05. What is the ratio of the Debt(current US$) in 1970 in Guinea to that in Haiti?
Your response must be concise. 25.22. What is the ratio of the Debt(current US$) of 1971 in Guinea to that in Haiti?
Offer a very short reply. 25.64. What is the ratio of the Debt(current US$) in 1972 in Guinea to that in Haiti?
Your answer should be compact. 5.77. What is the ratio of the Debt(current US$) of 1973 in Guinea to that in Haiti?
Your answer should be compact. 3.53. What is the ratio of the Debt(current US$) in 1970 in Guinea to that in Honduras?
Your answer should be very brief. 2.33. What is the ratio of the Debt(current US$) of 1971 in Guinea to that in Honduras?
Make the answer very short. 1.75. What is the ratio of the Debt(current US$) of 1972 in Guinea to that in Honduras?
Ensure brevity in your answer.  1.02. What is the ratio of the Debt(current US$) of 1973 in Guinea to that in Honduras?
Your answer should be very brief. 0.91. What is the ratio of the Debt(current US$) of 1970 in Guyana to that in Haiti?
Your answer should be compact. 7.64. What is the ratio of the Debt(current US$) in 1971 in Guyana to that in Haiti?
Your answer should be compact. 9.95. What is the ratio of the Debt(current US$) of 1972 in Guyana to that in Haiti?
Give a very brief answer. 5.64. What is the ratio of the Debt(current US$) of 1973 in Guyana to that in Haiti?
Offer a very short reply. 3.35. What is the ratio of the Debt(current US$) in 1970 in Guyana to that in Honduras?
Make the answer very short. 0.71. What is the ratio of the Debt(current US$) in 1971 in Guyana to that in Honduras?
Give a very brief answer. 0.68. What is the ratio of the Debt(current US$) in 1972 in Guyana to that in Honduras?
Provide a short and direct response. 1. What is the ratio of the Debt(current US$) of 1973 in Guyana to that in Honduras?
Provide a short and direct response. 0.86. What is the ratio of the Debt(current US$) in 1970 in Haiti to that in Honduras?
Provide a short and direct response. 0.09. What is the ratio of the Debt(current US$) of 1971 in Haiti to that in Honduras?
Your response must be concise. 0.07. What is the ratio of the Debt(current US$) of 1972 in Haiti to that in Honduras?
Your answer should be compact. 0.18. What is the ratio of the Debt(current US$) of 1973 in Haiti to that in Honduras?
Offer a terse response. 0.26. What is the difference between the highest and the second highest Debt(current US$) of 1970?
Keep it short and to the point. 7.56e+07. What is the difference between the highest and the second highest Debt(current US$) of 1971?
Provide a short and direct response. 3.40e+07. What is the difference between the highest and the second highest Debt(current US$) in 1972?
Offer a very short reply. 2.27e+07. What is the difference between the highest and the second highest Debt(current US$) in 1973?
Your answer should be very brief. 1.40e+07. What is the difference between the highest and the lowest Debt(current US$) in 1970?
Provide a short and direct response. 1.73e+08. What is the difference between the highest and the lowest Debt(current US$) of 1971?
Your answer should be very brief. 1.37e+08. What is the difference between the highest and the lowest Debt(current US$) of 1972?
Give a very brief answer. 1.02e+08. What is the difference between the highest and the lowest Debt(current US$) in 1973?
Give a very brief answer. 1.15e+08. 